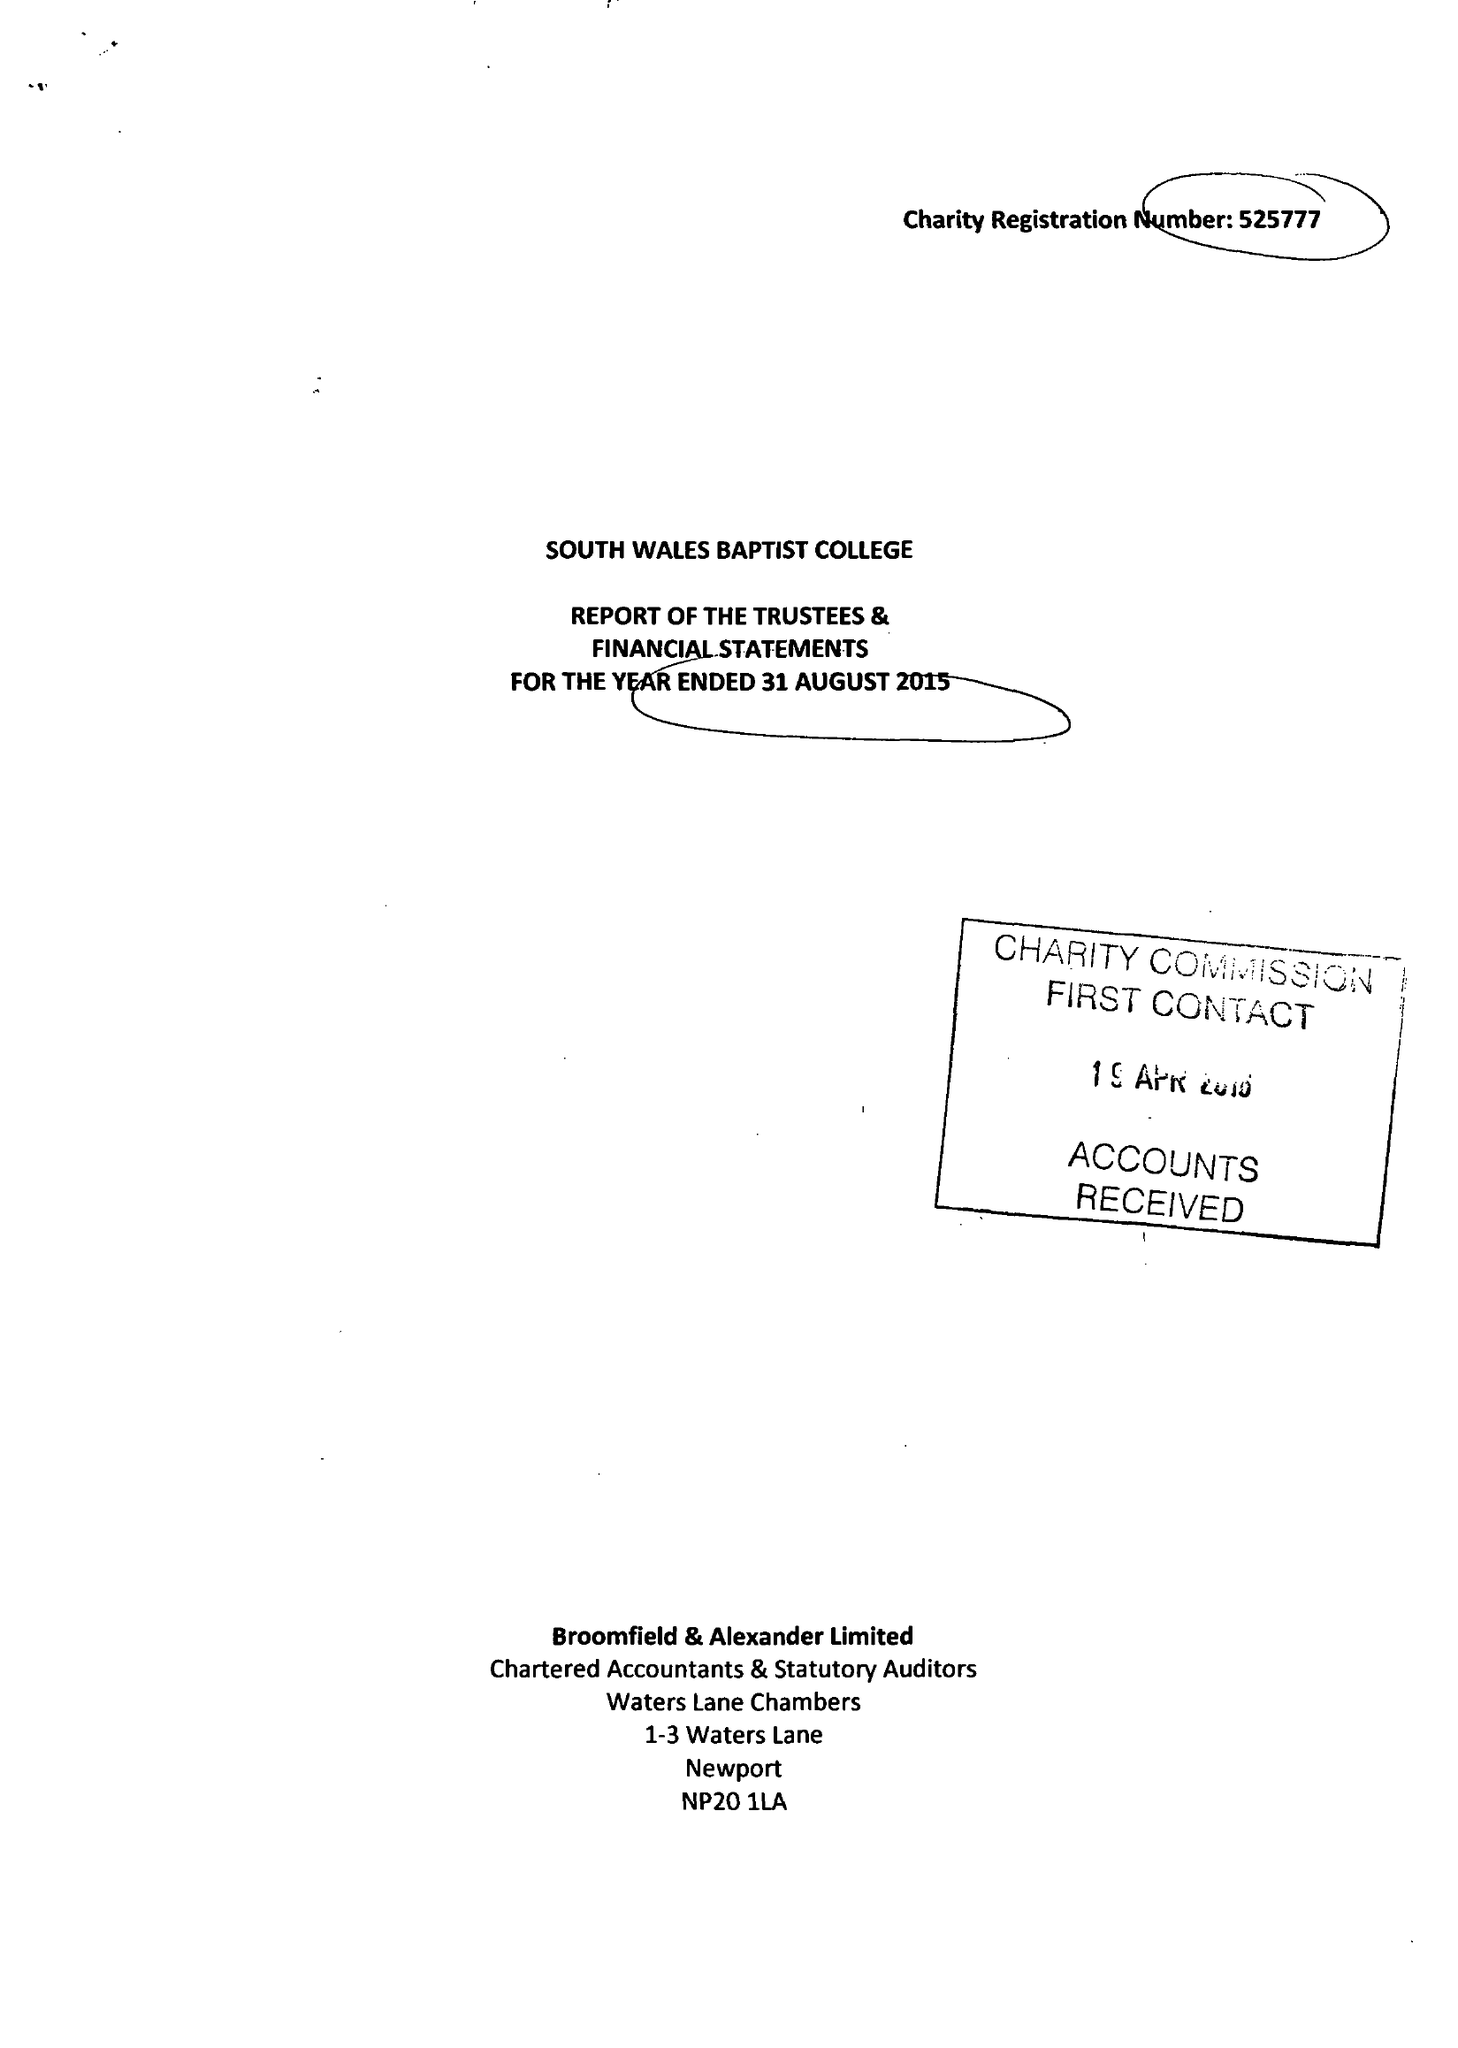What is the value for the report_date?
Answer the question using a single word or phrase. 2015-08-31 